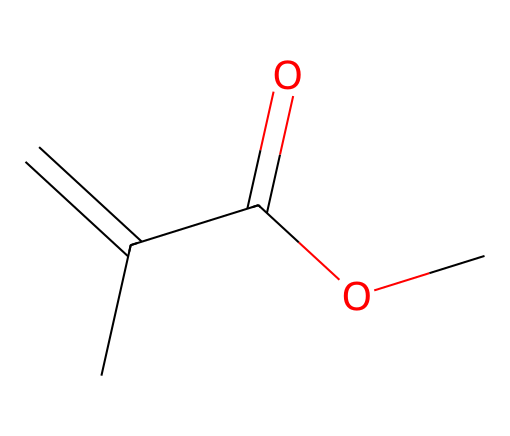What is the name of this chemical? The chemical structure corresponds to methyl methacrylate, which is indicated by the presence of the methacrylate group, characterized by the double bond and ester functional group.
Answer: methyl methacrylate How many carbon atoms are in the structure? By analyzing the SMILES representation, it can be seen that there are 5 carbon atoms present in the structure. This includes the carbons in the double bond and those attached to the carbonyl and ester functionalities.
Answer: 5 What type of functional group is present in methyl methacrylate? The presence of the -C(=O)O- portion of the structure indicates that the functional group is an ester. This is found by identifying the carbonyl (C=O) linked to an oxygen atom.
Answer: ester What is the degree of unsaturation in the structure? The degree of unsaturation can be determined by counting the double bonds and rings. The double bond contributes to one degree of unsaturation, and since there are no rings, the total degree of unsaturation is 1.
Answer: 1 How many hydrogen atoms are in methyl methacrylate? Counting the hydrogen atoms associated with each carbon in the structure reveals a total of 8 hydrogen atoms. This follows from the valency of carbon being satisfied by making up to four bonds.
Answer: 8 What type of monomer is methyl methacrylate classified as? Methyl methacrylate is classified as an acrylic monomer, as it is commonly used in the polymerization process to form acrylic polymers and is characterized by its vinyl and ester functional groups.
Answer: acrylic What is the function of the double bond in the structure? The double bond in methyl methacrylate allows for polymerization, which is crucial for forming long chains in polymer chemistry, providing reactivity that leads to the formation of a solid structure when polymerized.
Answer: polymerization 